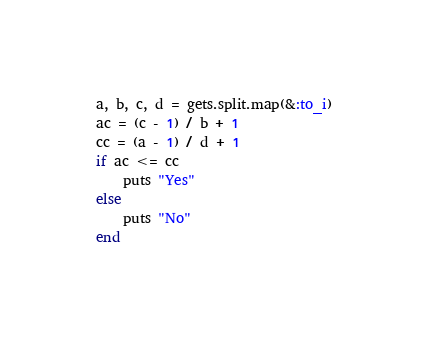<code> <loc_0><loc_0><loc_500><loc_500><_Ruby_>a, b, c, d = gets.split.map(&:to_i)
ac = (c - 1) / b + 1
cc = (a - 1) / d + 1
if ac <= cc
	puts "Yes"
else
	puts "No"
end</code> 